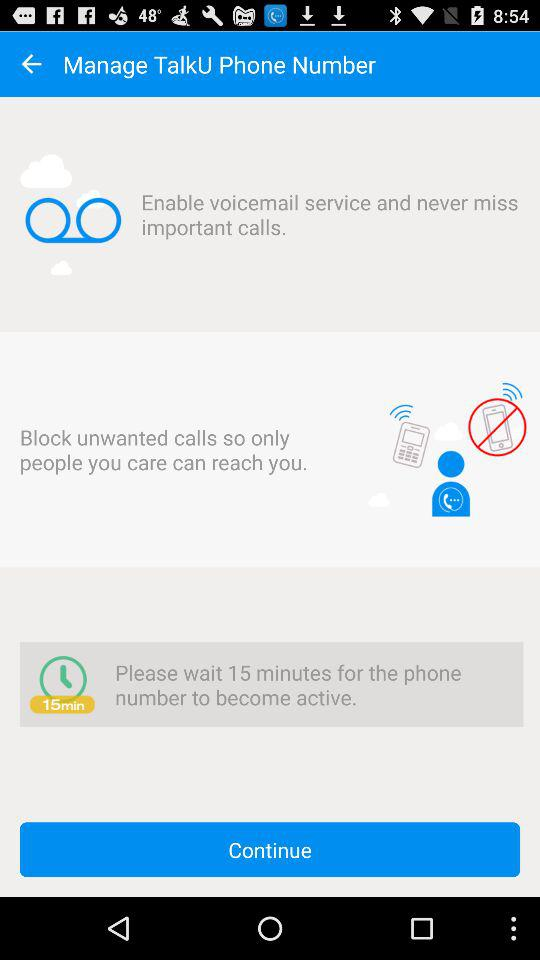What is the waiting time for the phone number to become active? The waiting time for the phone number to become active is 15 minutes. 